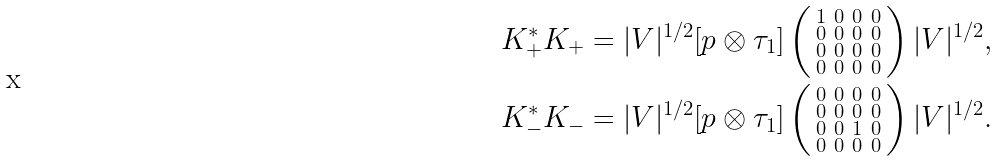<formula> <loc_0><loc_0><loc_500><loc_500>K ^ { \ast } _ { + } K _ { + } & = | V | ^ { 1 / 2 } [ p \otimes \tau _ { 1 } ] \left ( \begin{smallmatrix} 1 & 0 & 0 & 0 \\ 0 & 0 & 0 & 0 \\ 0 & 0 & 0 & 0 \\ 0 & 0 & 0 & 0 \end{smallmatrix} \right ) | V | ^ { 1 / 2 } , \\ K ^ { \ast } _ { - } K _ { - } & = | V | ^ { 1 / 2 } [ p \otimes \tau _ { 1 } ] \left ( \begin{smallmatrix} 0 & 0 & 0 & 0 \\ 0 & 0 & 0 & 0 \\ 0 & 0 & 1 & 0 \\ 0 & 0 & 0 & 0 \end{smallmatrix} \right ) | V | ^ { 1 / 2 } .</formula> 